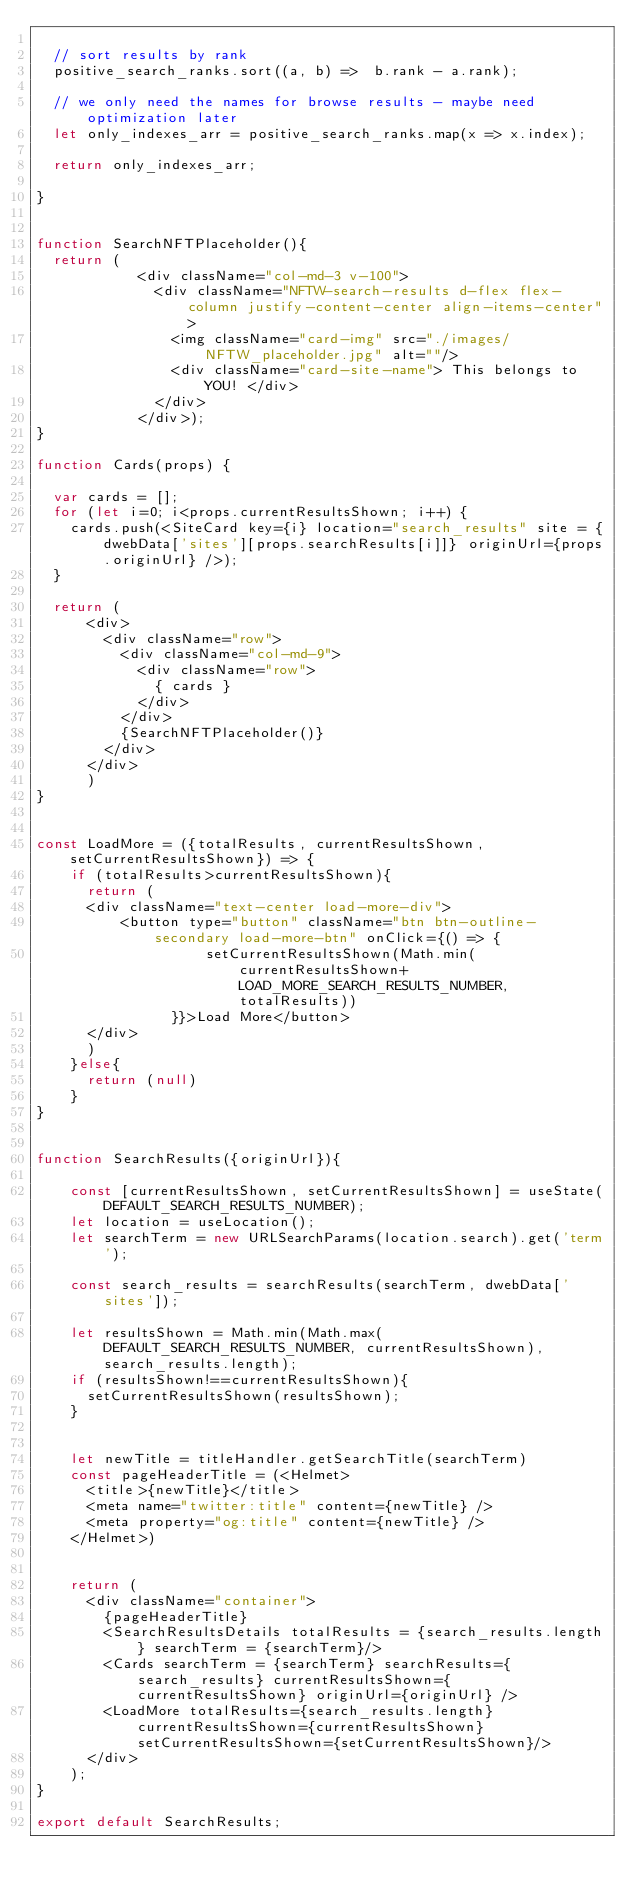Convert code to text. <code><loc_0><loc_0><loc_500><loc_500><_JavaScript_>
  // sort results by rank
  positive_search_ranks.sort((a, b) =>  b.rank - a.rank);

  // we only need the names for browse results - maybe need optimization later
  let only_indexes_arr = positive_search_ranks.map(x => x.index);

  return only_indexes_arr;

}


function SearchNFTPlaceholder(){
  return (
            <div className="col-md-3 v-100">
              <div className="NFTW-search-results d-flex flex-column justify-content-center align-items-center">
                <img className="card-img" src="./images/NFTW_placeholder.jpg" alt=""/>
                <div className="card-site-name"> This belongs to YOU! </div>
              </div>
            </div>);
}

function Cards(props) {

  var cards = [];
  for (let i=0; i<props.currentResultsShown; i++) {
    cards.push(<SiteCard key={i} location="search_results" site = {dwebData['sites'][props.searchResults[i]]} originUrl={props.originUrl} />);
  }

  return (
      <div>
        <div className="row">
          <div className="col-md-9">
            <div className="row">
              { cards }
            </div>
          </div>
          {SearchNFTPlaceholder()}
        </div>
      </div>
      )
}


const LoadMore = ({totalResults, currentResultsShown, setCurrentResultsShown}) => {
    if (totalResults>currentResultsShown){
      return (
      <div className="text-center load-more-div">
          <button type="button" className="btn btn-outline-secondary load-more-btn" onClick={() => {
                    setCurrentResultsShown(Math.min(currentResultsShown+LOAD_MORE_SEARCH_RESULTS_NUMBER, totalResults))
                }}>Load More</button>
      </div>
      )
    }else{
      return (null)
    }
}


function SearchResults({originUrl}){

    const [currentResultsShown, setCurrentResultsShown] = useState(DEFAULT_SEARCH_RESULTS_NUMBER);
    let location = useLocation();
    let searchTerm = new URLSearchParams(location.search).get('term');

    const search_results = searchResults(searchTerm, dwebData['sites']);

    let resultsShown = Math.min(Math.max(DEFAULT_SEARCH_RESULTS_NUMBER, currentResultsShown), search_results.length);
    if (resultsShown!==currentResultsShown){
      setCurrentResultsShown(resultsShown);
    }
    

    let newTitle = titleHandler.getSearchTitle(searchTerm)
    const pageHeaderTitle = (<Helmet>
      <title>{newTitle}</title>
      <meta name="twitter:title" content={newTitle} />
      <meta property="og:title" content={newTitle} />
    </Helmet>)

    
    return (
      <div className="container">
        {pageHeaderTitle}
        <SearchResultsDetails totalResults = {search_results.length} searchTerm = {searchTerm}/>
        <Cards searchTerm = {searchTerm} searchResults={search_results} currentResultsShown={currentResultsShown} originUrl={originUrl} />
        <LoadMore totalResults={search_results.length} currentResultsShown={currentResultsShown}  setCurrentResultsShown={setCurrentResultsShown}/> 
      </div>
    );
}

export default SearchResults;
</code> 